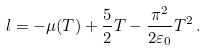<formula> <loc_0><loc_0><loc_500><loc_500>l = - \mu ( T ) + \frac { 5 } { 2 } T - \frac { \pi ^ { 2 } } { 2 \varepsilon _ { 0 } } T ^ { 2 } \, .</formula> 